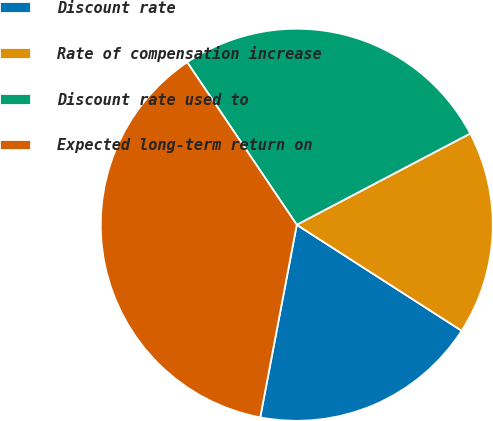<chart> <loc_0><loc_0><loc_500><loc_500><pie_chart><fcel>Discount rate<fcel>Rate of compensation increase<fcel>Discount rate used to<fcel>Expected long-term return on<nl><fcel>18.89%<fcel>16.8%<fcel>26.73%<fcel>37.57%<nl></chart> 